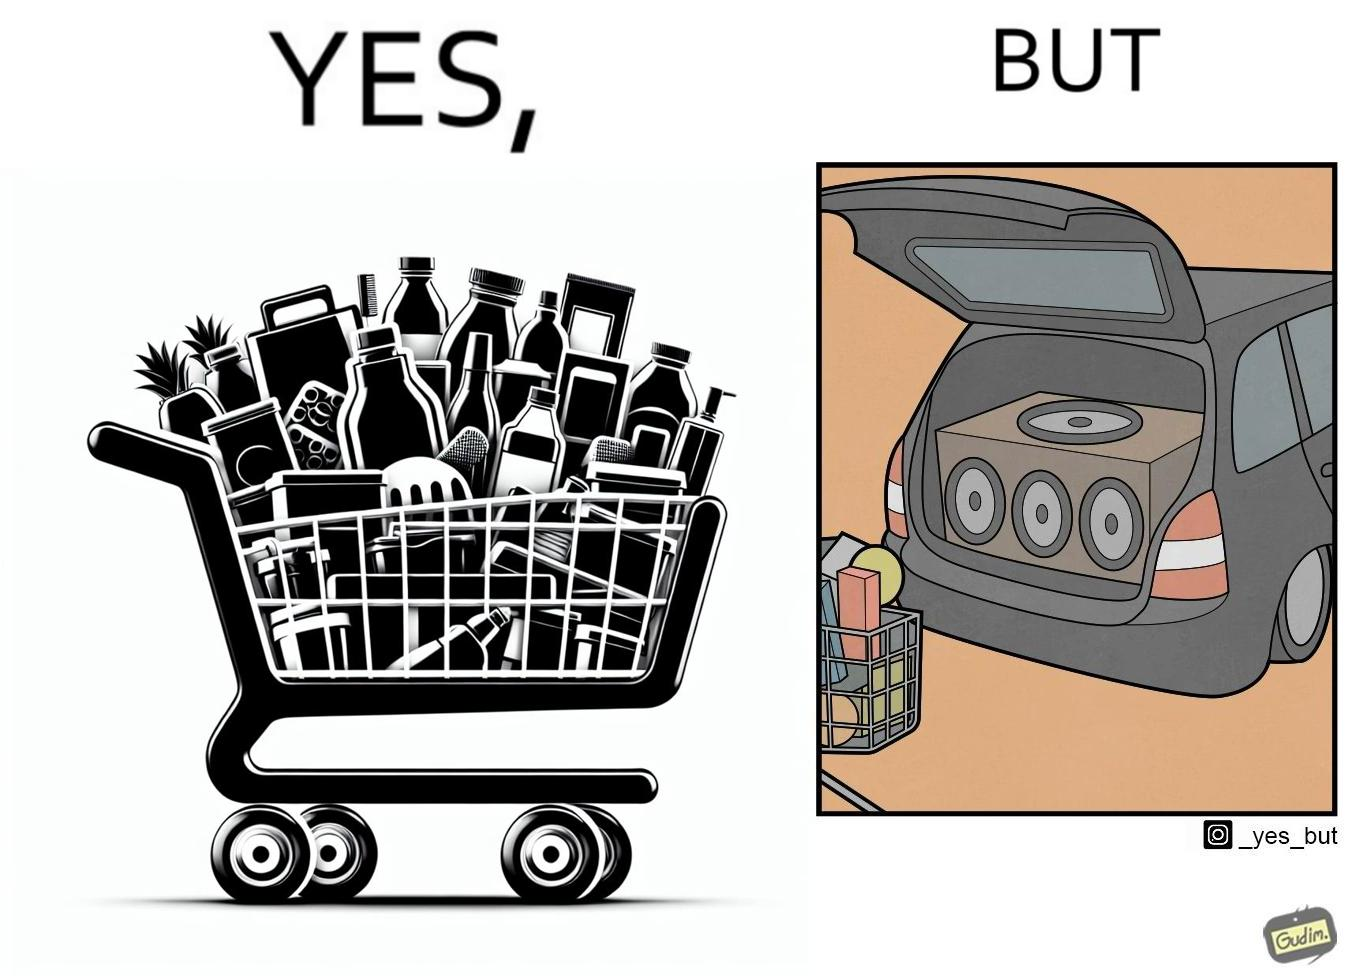Explain why this image is satirical. The image is ironic, because a car trunk was earlier designed to keep some extra luggage or things but people nowadays get speakers installed in the trunk which in turn reduces the space in the trunk and making it difficult for people to store the extra luggage in the trunk 